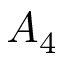<formula> <loc_0><loc_0><loc_500><loc_500>A _ { 4 }</formula> 